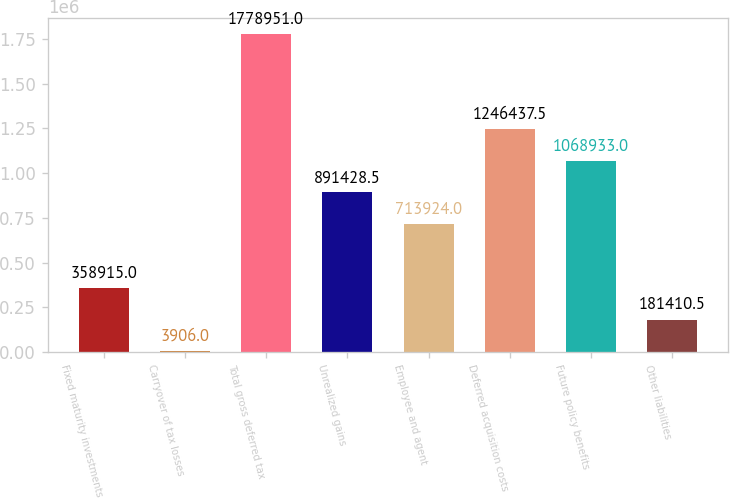Convert chart. <chart><loc_0><loc_0><loc_500><loc_500><bar_chart><fcel>Fixed maturity investments<fcel>Carryover of tax losses<fcel>Total gross deferred tax<fcel>Unrealized gains<fcel>Employee and agent<fcel>Deferred acquisition costs<fcel>Future policy benefits<fcel>Other liabilities<nl><fcel>358915<fcel>3906<fcel>1.77895e+06<fcel>891428<fcel>713924<fcel>1.24644e+06<fcel>1.06893e+06<fcel>181410<nl></chart> 